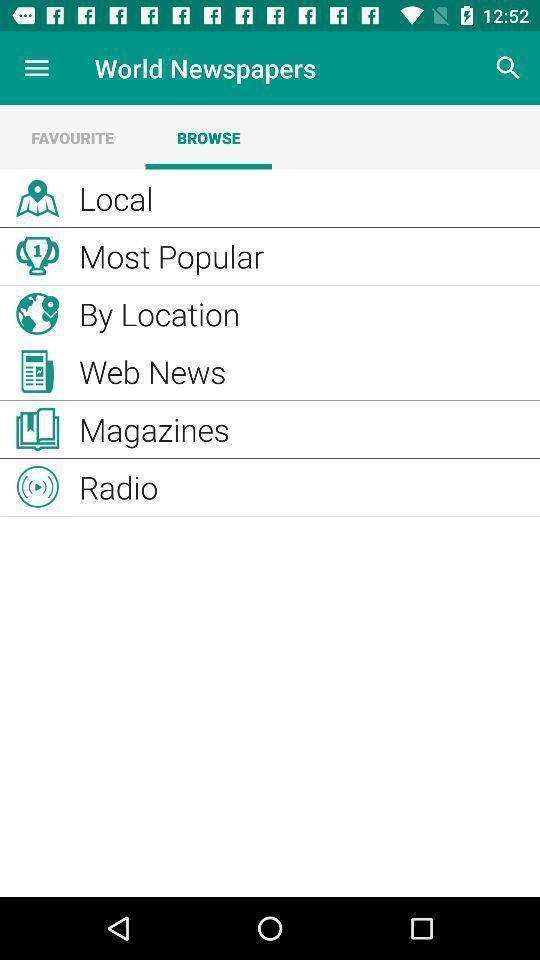Give me a narrative description of this picture. Search page shows to browse the list of news. 